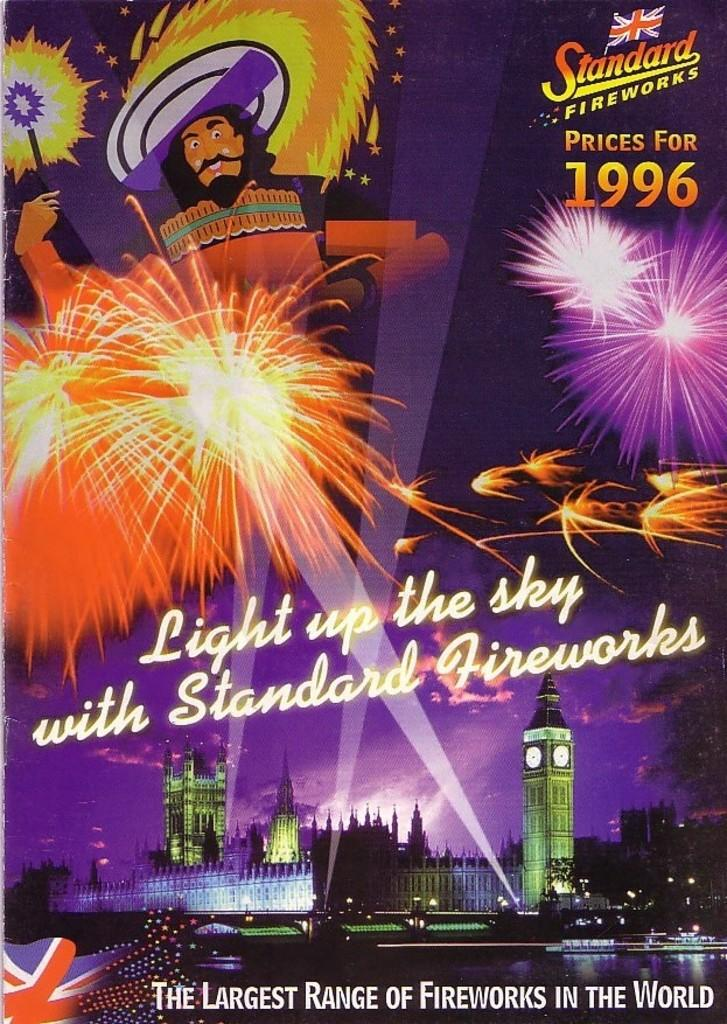Provide a one-sentence caption for the provided image. Light up the sky with standard fireworks prices for 1996. 